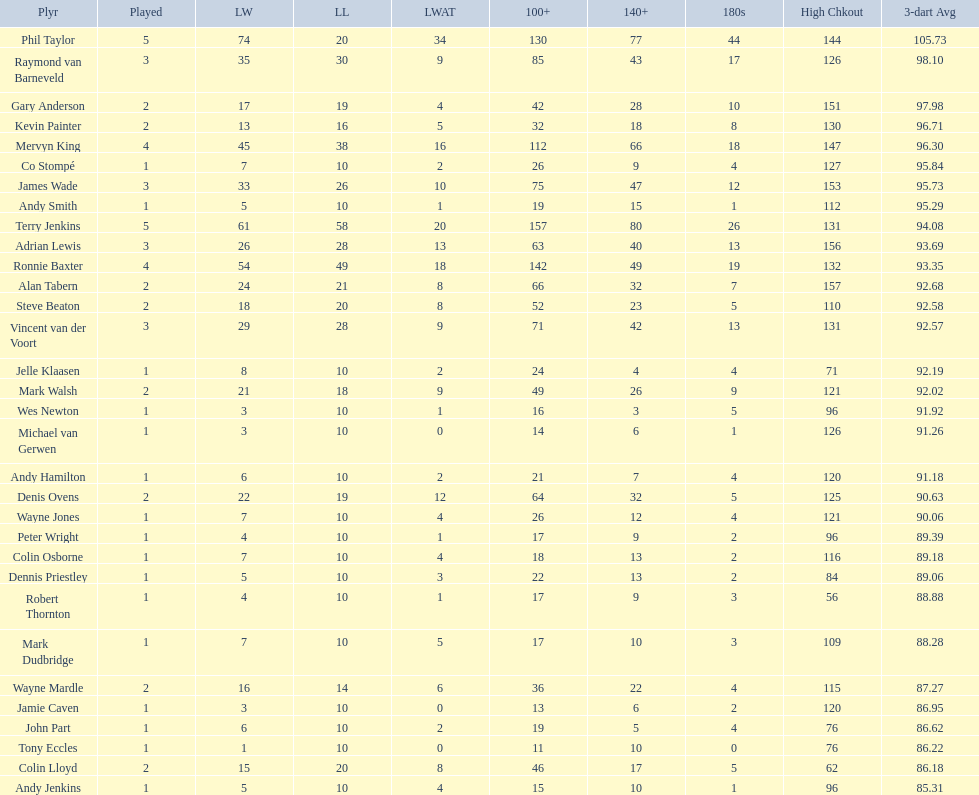Was andy smith or kevin painter's 3-dart average 96.71? Kevin Painter. Give me the full table as a dictionary. {'header': ['Plyr', 'Played', 'LW', 'LL', 'LWAT', '100+', '140+', '180s', 'High Chkout', '3-dart Avg'], 'rows': [['Phil Taylor', '5', '74', '20', '34', '130', '77', '44', '144', '105.73'], ['Raymond van Barneveld', '3', '35', '30', '9', '85', '43', '17', '126', '98.10'], ['Gary Anderson', '2', '17', '19', '4', '42', '28', '10', '151', '97.98'], ['Kevin Painter', '2', '13', '16', '5', '32', '18', '8', '130', '96.71'], ['Mervyn King', '4', '45', '38', '16', '112', '66', '18', '147', '96.30'], ['Co Stompé', '1', '7', '10', '2', '26', '9', '4', '127', '95.84'], ['James Wade', '3', '33', '26', '10', '75', '47', '12', '153', '95.73'], ['Andy Smith', '1', '5', '10', '1', '19', '15', '1', '112', '95.29'], ['Terry Jenkins', '5', '61', '58', '20', '157', '80', '26', '131', '94.08'], ['Adrian Lewis', '3', '26', '28', '13', '63', '40', '13', '156', '93.69'], ['Ronnie Baxter', '4', '54', '49', '18', '142', '49', '19', '132', '93.35'], ['Alan Tabern', '2', '24', '21', '8', '66', '32', '7', '157', '92.68'], ['Steve Beaton', '2', '18', '20', '8', '52', '23', '5', '110', '92.58'], ['Vincent van der Voort', '3', '29', '28', '9', '71', '42', '13', '131', '92.57'], ['Jelle Klaasen', '1', '8', '10', '2', '24', '4', '4', '71', '92.19'], ['Mark Walsh', '2', '21', '18', '9', '49', '26', '9', '121', '92.02'], ['Wes Newton', '1', '3', '10', '1', '16', '3', '5', '96', '91.92'], ['Michael van Gerwen', '1', '3', '10', '0', '14', '6', '1', '126', '91.26'], ['Andy Hamilton', '1', '6', '10', '2', '21', '7', '4', '120', '91.18'], ['Denis Ovens', '2', '22', '19', '12', '64', '32', '5', '125', '90.63'], ['Wayne Jones', '1', '7', '10', '4', '26', '12', '4', '121', '90.06'], ['Peter Wright', '1', '4', '10', '1', '17', '9', '2', '96', '89.39'], ['Colin Osborne', '1', '7', '10', '4', '18', '13', '2', '116', '89.18'], ['Dennis Priestley', '1', '5', '10', '3', '22', '13', '2', '84', '89.06'], ['Robert Thornton', '1', '4', '10', '1', '17', '9', '3', '56', '88.88'], ['Mark Dudbridge', '1', '7', '10', '5', '17', '10', '3', '109', '88.28'], ['Wayne Mardle', '2', '16', '14', '6', '36', '22', '4', '115', '87.27'], ['Jamie Caven', '1', '3', '10', '0', '13', '6', '2', '120', '86.95'], ['John Part', '1', '6', '10', '2', '19', '5', '4', '76', '86.62'], ['Tony Eccles', '1', '1', '10', '0', '11', '10', '0', '76', '86.22'], ['Colin Lloyd', '2', '15', '20', '8', '46', '17', '5', '62', '86.18'], ['Andy Jenkins', '1', '5', '10', '4', '15', '10', '1', '96', '85.31']]} 